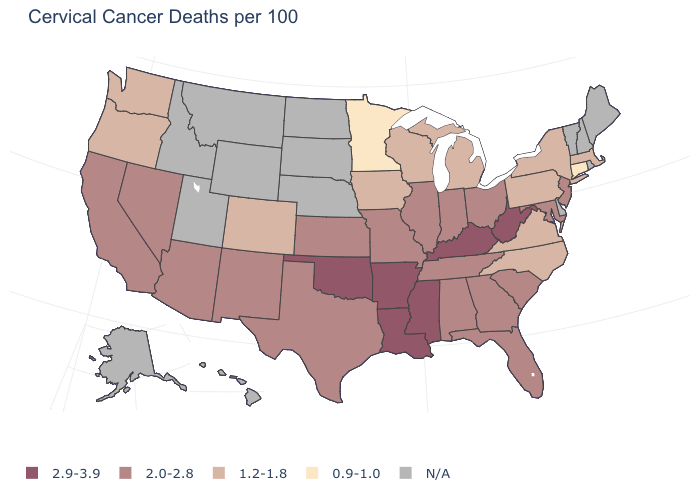Does the map have missing data?
Be succinct. Yes. What is the value of Massachusetts?
Answer briefly. 1.2-1.8. What is the value of Rhode Island?
Keep it brief. N/A. What is the value of New Hampshire?
Write a very short answer. N/A. What is the lowest value in the MidWest?
Write a very short answer. 0.9-1.0. Name the states that have a value in the range 0.9-1.0?
Answer briefly. Connecticut, Minnesota. Among the states that border Vermont , which have the highest value?
Be succinct. Massachusetts, New York. What is the lowest value in the MidWest?
Answer briefly. 0.9-1.0. What is the highest value in the USA?
Keep it brief. 2.9-3.9. What is the value of New Mexico?
Concise answer only. 2.0-2.8. Name the states that have a value in the range 0.9-1.0?
Write a very short answer. Connecticut, Minnesota. What is the highest value in states that border Connecticut?
Give a very brief answer. 1.2-1.8. 